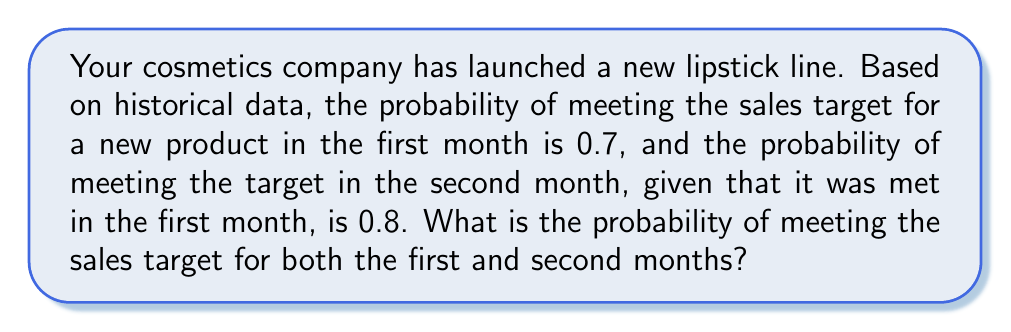Help me with this question. To solve this problem, we need to use the concept of conditional probability. Let's break it down step-by-step:

1. Let A be the event of meeting the sales target in the first month.
2. Let B be the event of meeting the sales target in the second month.

We are given:
- P(A) = 0.7 (probability of meeting the target in the first month)
- P(B|A) = 0.8 (probability of meeting the target in the second month, given it was met in the first month)

We want to find P(A and B), which is the probability of meeting the target in both months.

Using the multiplication rule of probability:

$$ P(A \text{ and } B) = P(A) \cdot P(B|A) $$

Substituting the given values:

$$ P(A \text{ and } B) = 0.7 \cdot 0.8 = 0.56 $$

Therefore, the probability of meeting the sales target for both the first and second months is 0.56 or 56%.
Answer: 0.56 